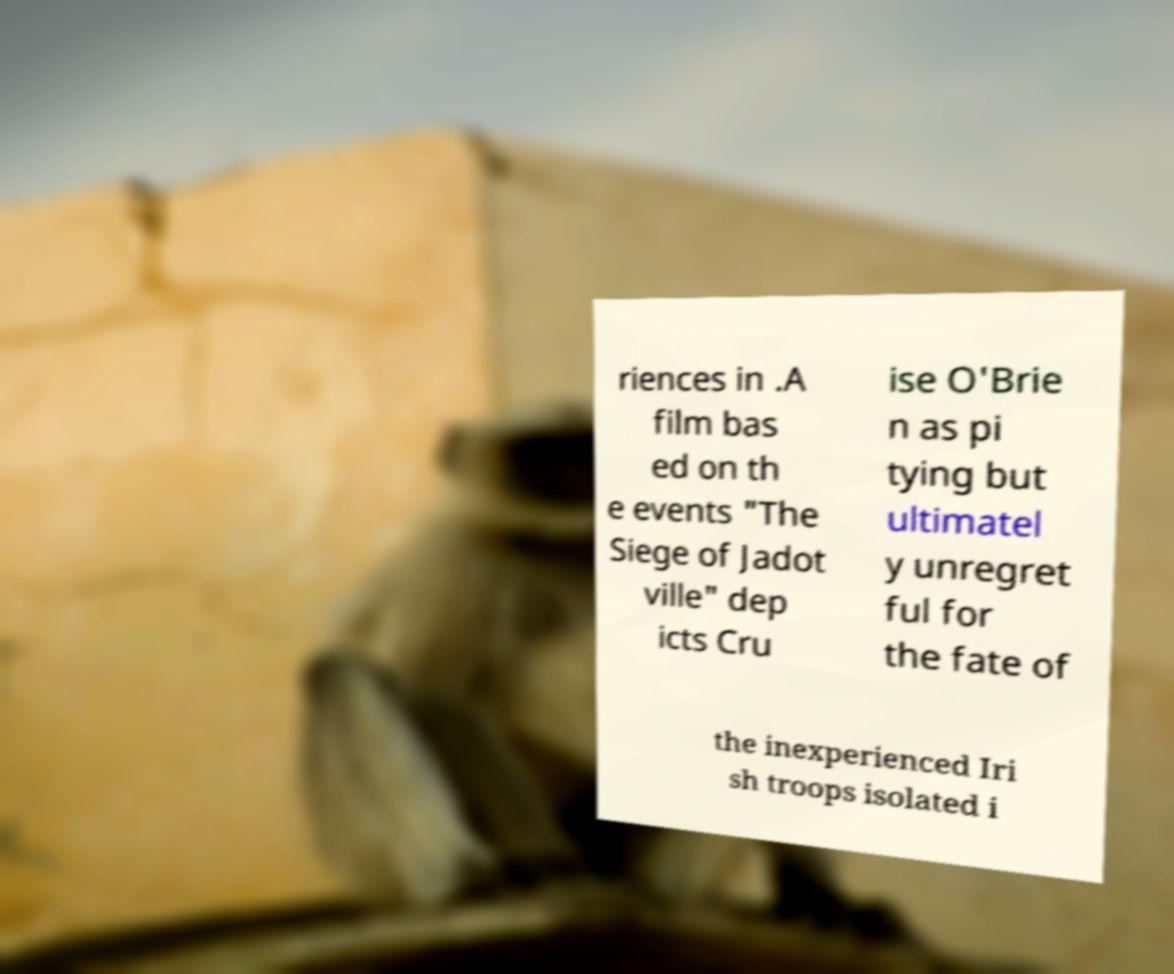I need the written content from this picture converted into text. Can you do that? riences in .A film bas ed on th e events "The Siege of Jadot ville" dep icts Cru ise O'Brie n as pi tying but ultimatel y unregret ful for the fate of the inexperienced Iri sh troops isolated i 